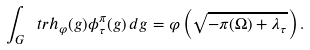Convert formula to latex. <formula><loc_0><loc_0><loc_500><loc_500>\int _ { G } \ t r h _ { \varphi } ( g ) \phi ^ { \pi } _ { \tau } ( g ) \, d g = \varphi \left ( \sqrt { - \pi ( \Omega ) + \lambda _ { \tau } } \right ) .</formula> 